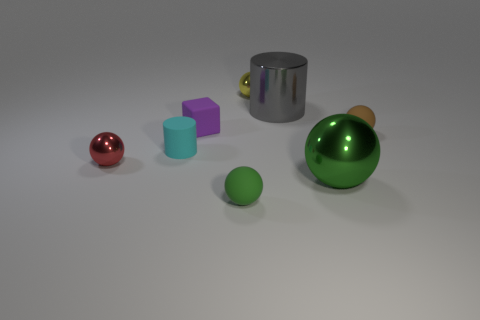How many green balls must be subtracted to get 1 green balls? 1 Subtract all tiny green rubber spheres. How many spheres are left? 4 Add 2 tiny rubber spheres. How many objects exist? 10 Subtract all cyan cylinders. How many cylinders are left? 1 Subtract 1 cubes. How many cubes are left? 0 Subtract all cyan spheres. Subtract all purple blocks. How many spheres are left? 5 Subtract all green blocks. How many green balls are left? 2 Subtract all cyan rubber cylinders. Subtract all rubber cylinders. How many objects are left? 6 Add 3 purple objects. How many purple objects are left? 4 Add 5 small matte things. How many small matte things exist? 9 